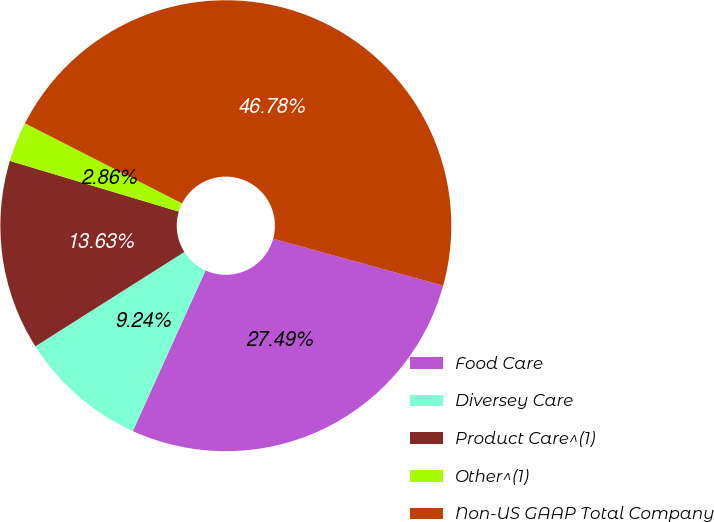<chart> <loc_0><loc_0><loc_500><loc_500><pie_chart><fcel>Food Care<fcel>Diversey Care<fcel>Product Care^(1)<fcel>Other^(1)<fcel>Non-US GAAP Total Company<nl><fcel>27.49%<fcel>9.24%<fcel>13.63%<fcel>2.86%<fcel>46.78%<nl></chart> 